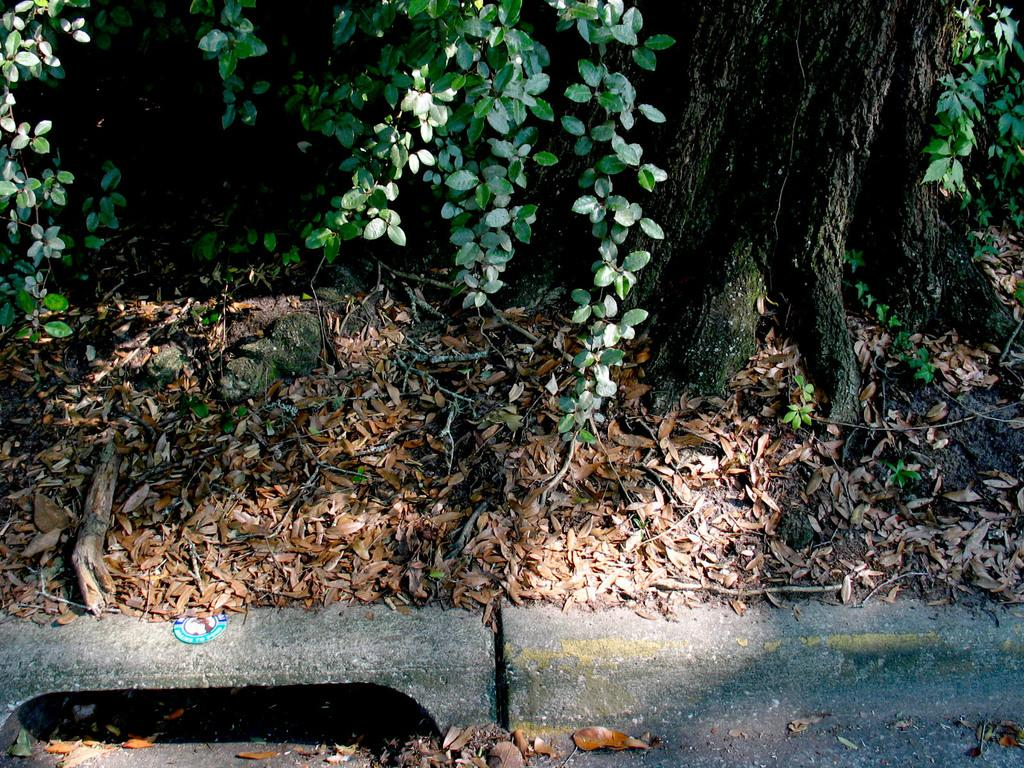What type of natural material is present on the surface in the image? There are dried leaves on the surface in the image. What else can be seen in the image besides the dried leaves? There is a branch visible in the image. Are there any green leaves present in the image? Yes, there are green leaves present in the image. What type of quartz can be seen in the image? There is no quartz present in the image. Is there a shop visible in the image? There is no shop visible in the image. 